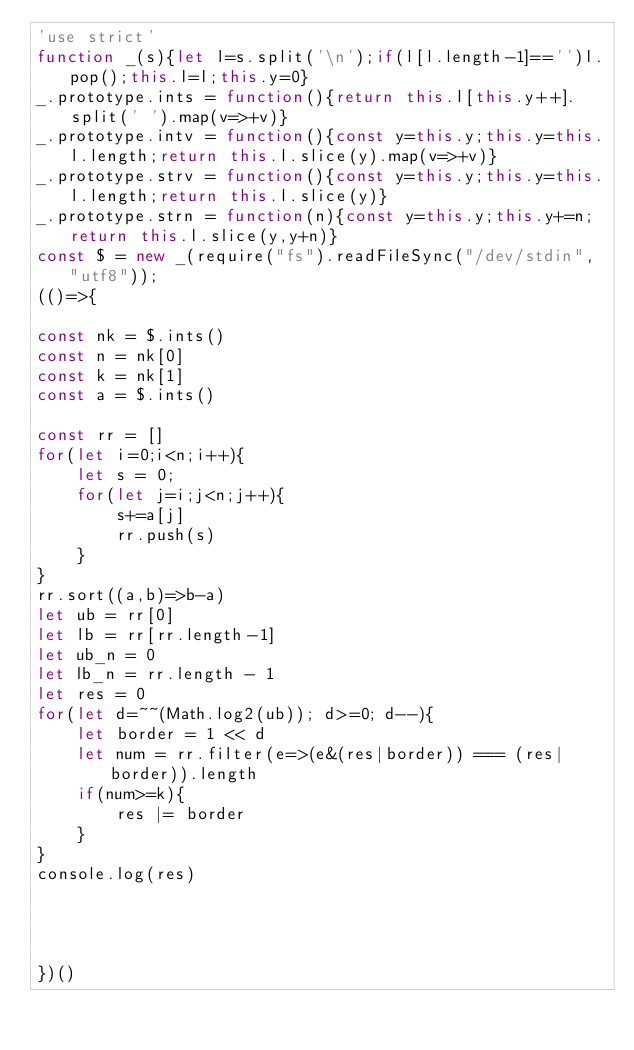<code> <loc_0><loc_0><loc_500><loc_500><_JavaScript_>'use strict'
function _(s){let l=s.split('\n');if(l[l.length-1]=='')l.pop();this.l=l;this.y=0}
_.prototype.ints = function(){return this.l[this.y++].split(' ').map(v=>+v)}
_.prototype.intv = function(){const y=this.y;this.y=this.l.length;return this.l.slice(y).map(v=>+v)}
_.prototype.strv = function(){const y=this.y;this.y=this.l.length;return this.l.slice(y)}
_.prototype.strn = function(n){const y=this.y;this.y+=n;return this.l.slice(y,y+n)}
const $ = new _(require("fs").readFileSync("/dev/stdin", "utf8"));
(()=>{

const nk = $.ints()
const n = nk[0]
const k = nk[1]
const a = $.ints()

const rr = []
for(let i=0;i<n;i++){
    let s = 0;
    for(let j=i;j<n;j++){
        s+=a[j]
        rr.push(s)
    }
}
rr.sort((a,b)=>b-a)
let ub = rr[0]
let lb = rr[rr.length-1]
let ub_n = 0
let lb_n = rr.length - 1
let res = 0
for(let d=~~(Math.log2(ub)); d>=0; d--){
    let border = 1 << d
    let num = rr.filter(e=>(e&(res|border)) === (res|border)).length
    if(num>=k){
        res |= border
    }
}
console.log(res)




})()</code> 